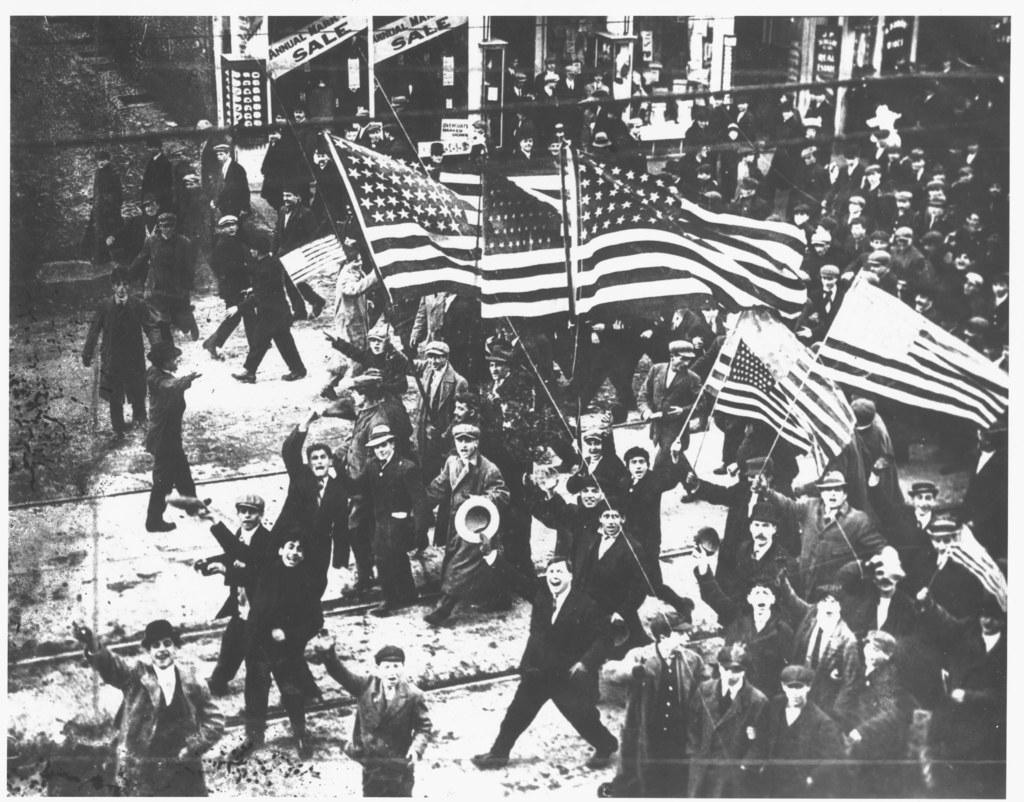What is the main subject of the image? The main subject of the image is a group of people. What are some of the people in the group doing? Some people in the group are holding flags. What is the color scheme of the image? The image is black and white in color. What type of operation is being performed by the people in the image? There is no indication of an operation being performed in the image; it simply shows a group of people holding flags. Can you confirm the existence of a pear in the image? There is no pear present in the image. 